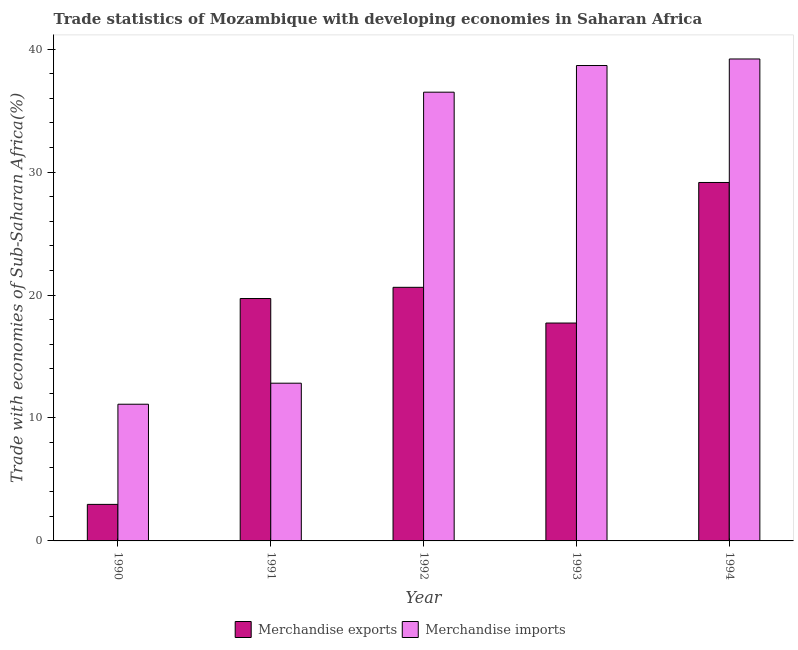How many groups of bars are there?
Your answer should be very brief. 5. Are the number of bars per tick equal to the number of legend labels?
Ensure brevity in your answer.  Yes. Are the number of bars on each tick of the X-axis equal?
Offer a terse response. Yes. What is the label of the 2nd group of bars from the left?
Ensure brevity in your answer.  1991. In how many cases, is the number of bars for a given year not equal to the number of legend labels?
Provide a succinct answer. 0. What is the merchandise exports in 1993?
Your response must be concise. 17.72. Across all years, what is the maximum merchandise exports?
Your response must be concise. 29.15. Across all years, what is the minimum merchandise exports?
Your answer should be very brief. 2.97. In which year was the merchandise imports maximum?
Your answer should be very brief. 1994. What is the total merchandise imports in the graph?
Offer a very short reply. 138.3. What is the difference between the merchandise exports in 1990 and that in 1994?
Offer a very short reply. -26.18. What is the difference between the merchandise imports in 1990 and the merchandise exports in 1994?
Your answer should be compact. -28.08. What is the average merchandise imports per year?
Provide a short and direct response. 27.66. In how many years, is the merchandise imports greater than 20 %?
Your answer should be very brief. 3. What is the ratio of the merchandise imports in 1993 to that in 1994?
Provide a succinct answer. 0.99. Is the merchandise exports in 1990 less than that in 1992?
Your answer should be compact. Yes. What is the difference between the highest and the second highest merchandise imports?
Offer a very short reply. 0.53. What is the difference between the highest and the lowest merchandise imports?
Make the answer very short. 28.08. What does the 2nd bar from the left in 1994 represents?
Your answer should be compact. Merchandise imports. What does the 1st bar from the right in 1990 represents?
Your answer should be very brief. Merchandise imports. How many bars are there?
Give a very brief answer. 10. Are all the bars in the graph horizontal?
Provide a short and direct response. No. How many years are there in the graph?
Offer a terse response. 5. What is the difference between two consecutive major ticks on the Y-axis?
Your answer should be compact. 10. Are the values on the major ticks of Y-axis written in scientific E-notation?
Keep it short and to the point. No. Does the graph contain grids?
Your response must be concise. No. Where does the legend appear in the graph?
Keep it short and to the point. Bottom center. How many legend labels are there?
Offer a very short reply. 2. How are the legend labels stacked?
Make the answer very short. Horizontal. What is the title of the graph?
Keep it short and to the point. Trade statistics of Mozambique with developing economies in Saharan Africa. What is the label or title of the X-axis?
Offer a very short reply. Year. What is the label or title of the Y-axis?
Offer a very short reply. Trade with economies of Sub-Saharan Africa(%). What is the Trade with economies of Sub-Saharan Africa(%) in Merchandise exports in 1990?
Make the answer very short. 2.97. What is the Trade with economies of Sub-Saharan Africa(%) of Merchandise imports in 1990?
Provide a short and direct response. 11.12. What is the Trade with economies of Sub-Saharan Africa(%) in Merchandise exports in 1991?
Your answer should be very brief. 19.71. What is the Trade with economies of Sub-Saharan Africa(%) of Merchandise imports in 1991?
Your response must be concise. 12.83. What is the Trade with economies of Sub-Saharan Africa(%) of Merchandise exports in 1992?
Your response must be concise. 20.63. What is the Trade with economies of Sub-Saharan Africa(%) of Merchandise imports in 1992?
Your answer should be compact. 36.5. What is the Trade with economies of Sub-Saharan Africa(%) of Merchandise exports in 1993?
Provide a short and direct response. 17.72. What is the Trade with economies of Sub-Saharan Africa(%) of Merchandise imports in 1993?
Make the answer very short. 38.66. What is the Trade with economies of Sub-Saharan Africa(%) of Merchandise exports in 1994?
Ensure brevity in your answer.  29.15. What is the Trade with economies of Sub-Saharan Africa(%) of Merchandise imports in 1994?
Make the answer very short. 39.2. Across all years, what is the maximum Trade with economies of Sub-Saharan Africa(%) of Merchandise exports?
Offer a terse response. 29.15. Across all years, what is the maximum Trade with economies of Sub-Saharan Africa(%) of Merchandise imports?
Give a very brief answer. 39.2. Across all years, what is the minimum Trade with economies of Sub-Saharan Africa(%) in Merchandise exports?
Your answer should be compact. 2.97. Across all years, what is the minimum Trade with economies of Sub-Saharan Africa(%) of Merchandise imports?
Your response must be concise. 11.12. What is the total Trade with economies of Sub-Saharan Africa(%) of Merchandise exports in the graph?
Offer a terse response. 90.18. What is the total Trade with economies of Sub-Saharan Africa(%) of Merchandise imports in the graph?
Offer a very short reply. 138.3. What is the difference between the Trade with economies of Sub-Saharan Africa(%) in Merchandise exports in 1990 and that in 1991?
Your response must be concise. -16.74. What is the difference between the Trade with economies of Sub-Saharan Africa(%) in Merchandise imports in 1990 and that in 1991?
Offer a very short reply. -1.71. What is the difference between the Trade with economies of Sub-Saharan Africa(%) in Merchandise exports in 1990 and that in 1992?
Your response must be concise. -17.65. What is the difference between the Trade with economies of Sub-Saharan Africa(%) in Merchandise imports in 1990 and that in 1992?
Give a very brief answer. -25.38. What is the difference between the Trade with economies of Sub-Saharan Africa(%) of Merchandise exports in 1990 and that in 1993?
Provide a short and direct response. -14.75. What is the difference between the Trade with economies of Sub-Saharan Africa(%) in Merchandise imports in 1990 and that in 1993?
Give a very brief answer. -27.55. What is the difference between the Trade with economies of Sub-Saharan Africa(%) of Merchandise exports in 1990 and that in 1994?
Offer a very short reply. -26.18. What is the difference between the Trade with economies of Sub-Saharan Africa(%) of Merchandise imports in 1990 and that in 1994?
Ensure brevity in your answer.  -28.08. What is the difference between the Trade with economies of Sub-Saharan Africa(%) of Merchandise exports in 1991 and that in 1992?
Your response must be concise. -0.91. What is the difference between the Trade with economies of Sub-Saharan Africa(%) in Merchandise imports in 1991 and that in 1992?
Ensure brevity in your answer.  -23.67. What is the difference between the Trade with economies of Sub-Saharan Africa(%) of Merchandise exports in 1991 and that in 1993?
Make the answer very short. 1.99. What is the difference between the Trade with economies of Sub-Saharan Africa(%) of Merchandise imports in 1991 and that in 1993?
Your answer should be very brief. -25.84. What is the difference between the Trade with economies of Sub-Saharan Africa(%) of Merchandise exports in 1991 and that in 1994?
Your response must be concise. -9.44. What is the difference between the Trade with economies of Sub-Saharan Africa(%) of Merchandise imports in 1991 and that in 1994?
Give a very brief answer. -26.37. What is the difference between the Trade with economies of Sub-Saharan Africa(%) in Merchandise exports in 1992 and that in 1993?
Provide a short and direct response. 2.9. What is the difference between the Trade with economies of Sub-Saharan Africa(%) in Merchandise imports in 1992 and that in 1993?
Make the answer very short. -2.17. What is the difference between the Trade with economies of Sub-Saharan Africa(%) in Merchandise exports in 1992 and that in 1994?
Give a very brief answer. -8.53. What is the difference between the Trade with economies of Sub-Saharan Africa(%) in Merchandise imports in 1992 and that in 1994?
Ensure brevity in your answer.  -2.7. What is the difference between the Trade with economies of Sub-Saharan Africa(%) in Merchandise exports in 1993 and that in 1994?
Offer a very short reply. -11.43. What is the difference between the Trade with economies of Sub-Saharan Africa(%) in Merchandise imports in 1993 and that in 1994?
Your answer should be compact. -0.53. What is the difference between the Trade with economies of Sub-Saharan Africa(%) in Merchandise exports in 1990 and the Trade with economies of Sub-Saharan Africa(%) in Merchandise imports in 1991?
Your response must be concise. -9.86. What is the difference between the Trade with economies of Sub-Saharan Africa(%) of Merchandise exports in 1990 and the Trade with economies of Sub-Saharan Africa(%) of Merchandise imports in 1992?
Keep it short and to the point. -33.52. What is the difference between the Trade with economies of Sub-Saharan Africa(%) of Merchandise exports in 1990 and the Trade with economies of Sub-Saharan Africa(%) of Merchandise imports in 1993?
Your answer should be very brief. -35.69. What is the difference between the Trade with economies of Sub-Saharan Africa(%) in Merchandise exports in 1990 and the Trade with economies of Sub-Saharan Africa(%) in Merchandise imports in 1994?
Give a very brief answer. -36.22. What is the difference between the Trade with economies of Sub-Saharan Africa(%) of Merchandise exports in 1991 and the Trade with economies of Sub-Saharan Africa(%) of Merchandise imports in 1992?
Offer a terse response. -16.78. What is the difference between the Trade with economies of Sub-Saharan Africa(%) of Merchandise exports in 1991 and the Trade with economies of Sub-Saharan Africa(%) of Merchandise imports in 1993?
Keep it short and to the point. -18.95. What is the difference between the Trade with economies of Sub-Saharan Africa(%) in Merchandise exports in 1991 and the Trade with economies of Sub-Saharan Africa(%) in Merchandise imports in 1994?
Your response must be concise. -19.48. What is the difference between the Trade with economies of Sub-Saharan Africa(%) in Merchandise exports in 1992 and the Trade with economies of Sub-Saharan Africa(%) in Merchandise imports in 1993?
Make the answer very short. -18.04. What is the difference between the Trade with economies of Sub-Saharan Africa(%) in Merchandise exports in 1992 and the Trade with economies of Sub-Saharan Africa(%) in Merchandise imports in 1994?
Keep it short and to the point. -18.57. What is the difference between the Trade with economies of Sub-Saharan Africa(%) in Merchandise exports in 1993 and the Trade with economies of Sub-Saharan Africa(%) in Merchandise imports in 1994?
Give a very brief answer. -21.48. What is the average Trade with economies of Sub-Saharan Africa(%) in Merchandise exports per year?
Give a very brief answer. 18.04. What is the average Trade with economies of Sub-Saharan Africa(%) of Merchandise imports per year?
Make the answer very short. 27.66. In the year 1990, what is the difference between the Trade with economies of Sub-Saharan Africa(%) of Merchandise exports and Trade with economies of Sub-Saharan Africa(%) of Merchandise imports?
Provide a succinct answer. -8.15. In the year 1991, what is the difference between the Trade with economies of Sub-Saharan Africa(%) of Merchandise exports and Trade with economies of Sub-Saharan Africa(%) of Merchandise imports?
Make the answer very short. 6.89. In the year 1992, what is the difference between the Trade with economies of Sub-Saharan Africa(%) in Merchandise exports and Trade with economies of Sub-Saharan Africa(%) in Merchandise imports?
Keep it short and to the point. -15.87. In the year 1993, what is the difference between the Trade with economies of Sub-Saharan Africa(%) of Merchandise exports and Trade with economies of Sub-Saharan Africa(%) of Merchandise imports?
Ensure brevity in your answer.  -20.94. In the year 1994, what is the difference between the Trade with economies of Sub-Saharan Africa(%) in Merchandise exports and Trade with economies of Sub-Saharan Africa(%) in Merchandise imports?
Provide a succinct answer. -10.04. What is the ratio of the Trade with economies of Sub-Saharan Africa(%) of Merchandise exports in 1990 to that in 1991?
Give a very brief answer. 0.15. What is the ratio of the Trade with economies of Sub-Saharan Africa(%) of Merchandise imports in 1990 to that in 1991?
Provide a succinct answer. 0.87. What is the ratio of the Trade with economies of Sub-Saharan Africa(%) in Merchandise exports in 1990 to that in 1992?
Provide a succinct answer. 0.14. What is the ratio of the Trade with economies of Sub-Saharan Africa(%) in Merchandise imports in 1990 to that in 1992?
Offer a terse response. 0.3. What is the ratio of the Trade with economies of Sub-Saharan Africa(%) of Merchandise exports in 1990 to that in 1993?
Your answer should be compact. 0.17. What is the ratio of the Trade with economies of Sub-Saharan Africa(%) of Merchandise imports in 1990 to that in 1993?
Keep it short and to the point. 0.29. What is the ratio of the Trade with economies of Sub-Saharan Africa(%) in Merchandise exports in 1990 to that in 1994?
Provide a succinct answer. 0.1. What is the ratio of the Trade with economies of Sub-Saharan Africa(%) in Merchandise imports in 1990 to that in 1994?
Your answer should be compact. 0.28. What is the ratio of the Trade with economies of Sub-Saharan Africa(%) of Merchandise exports in 1991 to that in 1992?
Ensure brevity in your answer.  0.96. What is the ratio of the Trade with economies of Sub-Saharan Africa(%) of Merchandise imports in 1991 to that in 1992?
Give a very brief answer. 0.35. What is the ratio of the Trade with economies of Sub-Saharan Africa(%) in Merchandise exports in 1991 to that in 1993?
Provide a short and direct response. 1.11. What is the ratio of the Trade with economies of Sub-Saharan Africa(%) of Merchandise imports in 1991 to that in 1993?
Your answer should be very brief. 0.33. What is the ratio of the Trade with economies of Sub-Saharan Africa(%) in Merchandise exports in 1991 to that in 1994?
Provide a succinct answer. 0.68. What is the ratio of the Trade with economies of Sub-Saharan Africa(%) in Merchandise imports in 1991 to that in 1994?
Keep it short and to the point. 0.33. What is the ratio of the Trade with economies of Sub-Saharan Africa(%) in Merchandise exports in 1992 to that in 1993?
Your answer should be very brief. 1.16. What is the ratio of the Trade with economies of Sub-Saharan Africa(%) in Merchandise imports in 1992 to that in 1993?
Your response must be concise. 0.94. What is the ratio of the Trade with economies of Sub-Saharan Africa(%) of Merchandise exports in 1992 to that in 1994?
Offer a very short reply. 0.71. What is the ratio of the Trade with economies of Sub-Saharan Africa(%) in Merchandise imports in 1992 to that in 1994?
Your response must be concise. 0.93. What is the ratio of the Trade with economies of Sub-Saharan Africa(%) in Merchandise exports in 1993 to that in 1994?
Ensure brevity in your answer.  0.61. What is the ratio of the Trade with economies of Sub-Saharan Africa(%) in Merchandise imports in 1993 to that in 1994?
Your response must be concise. 0.99. What is the difference between the highest and the second highest Trade with economies of Sub-Saharan Africa(%) in Merchandise exports?
Offer a very short reply. 8.53. What is the difference between the highest and the second highest Trade with economies of Sub-Saharan Africa(%) of Merchandise imports?
Ensure brevity in your answer.  0.53. What is the difference between the highest and the lowest Trade with economies of Sub-Saharan Africa(%) in Merchandise exports?
Offer a terse response. 26.18. What is the difference between the highest and the lowest Trade with economies of Sub-Saharan Africa(%) in Merchandise imports?
Provide a short and direct response. 28.08. 